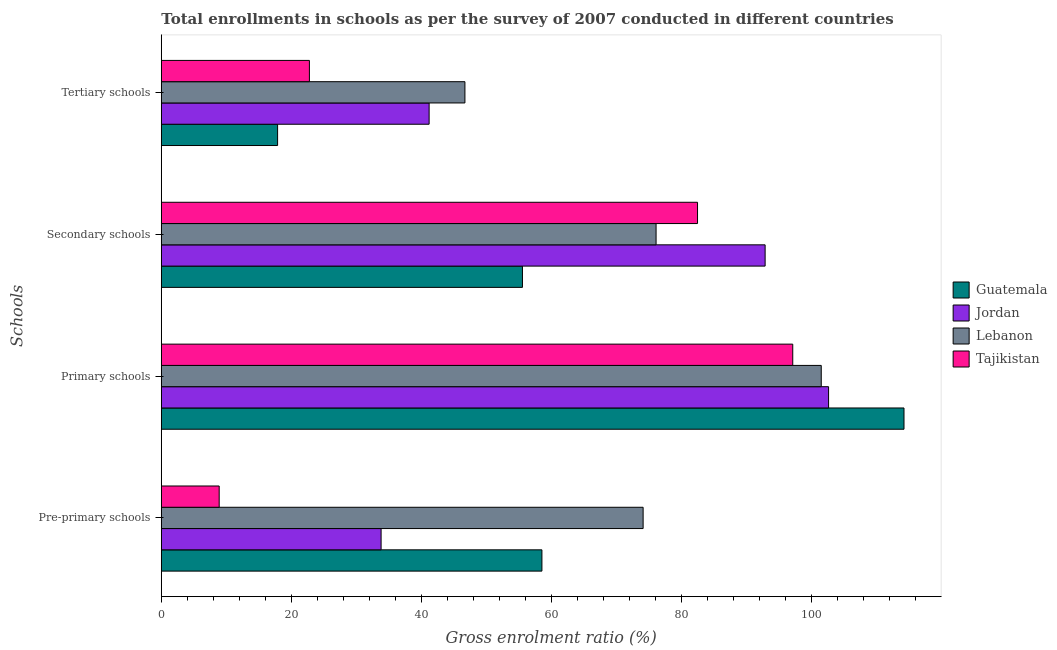How many different coloured bars are there?
Your answer should be compact. 4. Are the number of bars per tick equal to the number of legend labels?
Give a very brief answer. Yes. How many bars are there on the 4th tick from the top?
Your answer should be compact. 4. What is the label of the 2nd group of bars from the top?
Your response must be concise. Secondary schools. What is the gross enrolment ratio in tertiary schools in Guatemala?
Offer a very short reply. 17.88. Across all countries, what is the maximum gross enrolment ratio in primary schools?
Keep it short and to the point. 114.17. Across all countries, what is the minimum gross enrolment ratio in pre-primary schools?
Ensure brevity in your answer.  8.9. In which country was the gross enrolment ratio in tertiary schools maximum?
Your response must be concise. Lebanon. In which country was the gross enrolment ratio in tertiary schools minimum?
Ensure brevity in your answer.  Guatemala. What is the total gross enrolment ratio in pre-primary schools in the graph?
Offer a very short reply. 175.25. What is the difference between the gross enrolment ratio in pre-primary schools in Guatemala and that in Jordan?
Give a very brief answer. 24.72. What is the difference between the gross enrolment ratio in secondary schools in Jordan and the gross enrolment ratio in tertiary schools in Tajikistan?
Give a very brief answer. 70.05. What is the average gross enrolment ratio in primary schools per country?
Your response must be concise. 103.81. What is the difference between the gross enrolment ratio in primary schools and gross enrolment ratio in secondary schools in Guatemala?
Offer a terse response. 58.65. In how many countries, is the gross enrolment ratio in pre-primary schools greater than 12 %?
Your response must be concise. 3. What is the ratio of the gross enrolment ratio in tertiary schools in Lebanon to that in Guatemala?
Offer a very short reply. 2.61. Is the difference between the gross enrolment ratio in secondary schools in Jordan and Tajikistan greater than the difference between the gross enrolment ratio in pre-primary schools in Jordan and Tajikistan?
Offer a very short reply. No. What is the difference between the highest and the second highest gross enrolment ratio in pre-primary schools?
Provide a succinct answer. 15.56. What is the difference between the highest and the lowest gross enrolment ratio in secondary schools?
Your response must be concise. 37.3. Is the sum of the gross enrolment ratio in pre-primary schools in Lebanon and Tajikistan greater than the maximum gross enrolment ratio in secondary schools across all countries?
Keep it short and to the point. No. What does the 1st bar from the top in Secondary schools represents?
Your answer should be compact. Tajikistan. What does the 2nd bar from the bottom in Pre-primary schools represents?
Provide a short and direct response. Jordan. Is it the case that in every country, the sum of the gross enrolment ratio in pre-primary schools and gross enrolment ratio in primary schools is greater than the gross enrolment ratio in secondary schools?
Ensure brevity in your answer.  Yes. How many countries are there in the graph?
Provide a succinct answer. 4. What is the difference between two consecutive major ticks on the X-axis?
Make the answer very short. 20. Does the graph contain any zero values?
Give a very brief answer. No. Where does the legend appear in the graph?
Give a very brief answer. Center right. How many legend labels are there?
Give a very brief answer. 4. How are the legend labels stacked?
Provide a short and direct response. Vertical. What is the title of the graph?
Your answer should be very brief. Total enrollments in schools as per the survey of 2007 conducted in different countries. What is the label or title of the X-axis?
Provide a short and direct response. Gross enrolment ratio (%). What is the label or title of the Y-axis?
Provide a succinct answer. Schools. What is the Gross enrolment ratio (%) in Guatemala in Pre-primary schools?
Make the answer very short. 58.51. What is the Gross enrolment ratio (%) of Jordan in Pre-primary schools?
Make the answer very short. 33.78. What is the Gross enrolment ratio (%) of Lebanon in Pre-primary schools?
Provide a short and direct response. 74.07. What is the Gross enrolment ratio (%) of Tajikistan in Pre-primary schools?
Provide a succinct answer. 8.9. What is the Gross enrolment ratio (%) in Guatemala in Primary schools?
Your answer should be compact. 114.17. What is the Gross enrolment ratio (%) of Jordan in Primary schools?
Provide a short and direct response. 102.57. What is the Gross enrolment ratio (%) in Lebanon in Primary schools?
Keep it short and to the point. 101.45. What is the Gross enrolment ratio (%) in Tajikistan in Primary schools?
Your answer should be compact. 97.07. What is the Gross enrolment ratio (%) in Guatemala in Secondary schools?
Offer a very short reply. 55.51. What is the Gross enrolment ratio (%) of Jordan in Secondary schools?
Provide a succinct answer. 92.82. What is the Gross enrolment ratio (%) of Lebanon in Secondary schools?
Your response must be concise. 76.06. What is the Gross enrolment ratio (%) of Tajikistan in Secondary schools?
Provide a succinct answer. 82.43. What is the Gross enrolment ratio (%) in Guatemala in Tertiary schools?
Your answer should be very brief. 17.88. What is the Gross enrolment ratio (%) in Jordan in Tertiary schools?
Your answer should be very brief. 41.17. What is the Gross enrolment ratio (%) in Lebanon in Tertiary schools?
Your answer should be compact. 46.67. What is the Gross enrolment ratio (%) of Tajikistan in Tertiary schools?
Offer a very short reply. 22.76. Across all Schools, what is the maximum Gross enrolment ratio (%) in Guatemala?
Your response must be concise. 114.17. Across all Schools, what is the maximum Gross enrolment ratio (%) in Jordan?
Your response must be concise. 102.57. Across all Schools, what is the maximum Gross enrolment ratio (%) of Lebanon?
Offer a very short reply. 101.45. Across all Schools, what is the maximum Gross enrolment ratio (%) in Tajikistan?
Provide a succinct answer. 97.07. Across all Schools, what is the minimum Gross enrolment ratio (%) in Guatemala?
Ensure brevity in your answer.  17.88. Across all Schools, what is the minimum Gross enrolment ratio (%) of Jordan?
Ensure brevity in your answer.  33.78. Across all Schools, what is the minimum Gross enrolment ratio (%) of Lebanon?
Your answer should be very brief. 46.67. Across all Schools, what is the minimum Gross enrolment ratio (%) of Tajikistan?
Ensure brevity in your answer.  8.9. What is the total Gross enrolment ratio (%) in Guatemala in the graph?
Keep it short and to the point. 246.06. What is the total Gross enrolment ratio (%) in Jordan in the graph?
Provide a succinct answer. 270.35. What is the total Gross enrolment ratio (%) in Lebanon in the graph?
Your answer should be very brief. 298.24. What is the total Gross enrolment ratio (%) in Tajikistan in the graph?
Make the answer very short. 211.15. What is the difference between the Gross enrolment ratio (%) of Guatemala in Pre-primary schools and that in Primary schools?
Provide a succinct answer. -55.66. What is the difference between the Gross enrolment ratio (%) in Jordan in Pre-primary schools and that in Primary schools?
Keep it short and to the point. -68.79. What is the difference between the Gross enrolment ratio (%) of Lebanon in Pre-primary schools and that in Primary schools?
Ensure brevity in your answer.  -27.38. What is the difference between the Gross enrolment ratio (%) of Tajikistan in Pre-primary schools and that in Primary schools?
Offer a terse response. -88.17. What is the difference between the Gross enrolment ratio (%) of Guatemala in Pre-primary schools and that in Secondary schools?
Provide a succinct answer. 2.99. What is the difference between the Gross enrolment ratio (%) of Jordan in Pre-primary schools and that in Secondary schools?
Make the answer very short. -59.03. What is the difference between the Gross enrolment ratio (%) of Lebanon in Pre-primary schools and that in Secondary schools?
Offer a very short reply. -1.99. What is the difference between the Gross enrolment ratio (%) in Tajikistan in Pre-primary schools and that in Secondary schools?
Ensure brevity in your answer.  -73.53. What is the difference between the Gross enrolment ratio (%) of Guatemala in Pre-primary schools and that in Tertiary schools?
Your response must be concise. 40.63. What is the difference between the Gross enrolment ratio (%) in Jordan in Pre-primary schools and that in Tertiary schools?
Keep it short and to the point. -7.38. What is the difference between the Gross enrolment ratio (%) in Lebanon in Pre-primary schools and that in Tertiary schools?
Ensure brevity in your answer.  27.39. What is the difference between the Gross enrolment ratio (%) of Tajikistan in Pre-primary schools and that in Tertiary schools?
Your answer should be compact. -13.87. What is the difference between the Gross enrolment ratio (%) in Guatemala in Primary schools and that in Secondary schools?
Make the answer very short. 58.65. What is the difference between the Gross enrolment ratio (%) in Jordan in Primary schools and that in Secondary schools?
Keep it short and to the point. 9.76. What is the difference between the Gross enrolment ratio (%) of Lebanon in Primary schools and that in Secondary schools?
Your answer should be compact. 25.39. What is the difference between the Gross enrolment ratio (%) in Tajikistan in Primary schools and that in Secondary schools?
Give a very brief answer. 14.64. What is the difference between the Gross enrolment ratio (%) of Guatemala in Primary schools and that in Tertiary schools?
Give a very brief answer. 96.29. What is the difference between the Gross enrolment ratio (%) of Jordan in Primary schools and that in Tertiary schools?
Provide a short and direct response. 61.41. What is the difference between the Gross enrolment ratio (%) of Lebanon in Primary schools and that in Tertiary schools?
Give a very brief answer. 54.77. What is the difference between the Gross enrolment ratio (%) of Tajikistan in Primary schools and that in Tertiary schools?
Provide a short and direct response. 74.3. What is the difference between the Gross enrolment ratio (%) in Guatemala in Secondary schools and that in Tertiary schools?
Your answer should be compact. 37.64. What is the difference between the Gross enrolment ratio (%) in Jordan in Secondary schools and that in Tertiary schools?
Ensure brevity in your answer.  51.65. What is the difference between the Gross enrolment ratio (%) of Lebanon in Secondary schools and that in Tertiary schools?
Ensure brevity in your answer.  29.38. What is the difference between the Gross enrolment ratio (%) of Tajikistan in Secondary schools and that in Tertiary schools?
Your answer should be compact. 59.66. What is the difference between the Gross enrolment ratio (%) in Guatemala in Pre-primary schools and the Gross enrolment ratio (%) in Jordan in Primary schools?
Keep it short and to the point. -44.07. What is the difference between the Gross enrolment ratio (%) in Guatemala in Pre-primary schools and the Gross enrolment ratio (%) in Lebanon in Primary schools?
Ensure brevity in your answer.  -42.94. What is the difference between the Gross enrolment ratio (%) of Guatemala in Pre-primary schools and the Gross enrolment ratio (%) of Tajikistan in Primary schools?
Provide a succinct answer. -38.56. What is the difference between the Gross enrolment ratio (%) of Jordan in Pre-primary schools and the Gross enrolment ratio (%) of Lebanon in Primary schools?
Offer a terse response. -67.66. What is the difference between the Gross enrolment ratio (%) of Jordan in Pre-primary schools and the Gross enrolment ratio (%) of Tajikistan in Primary schools?
Keep it short and to the point. -63.28. What is the difference between the Gross enrolment ratio (%) of Lebanon in Pre-primary schools and the Gross enrolment ratio (%) of Tajikistan in Primary schools?
Your answer should be very brief. -23. What is the difference between the Gross enrolment ratio (%) of Guatemala in Pre-primary schools and the Gross enrolment ratio (%) of Jordan in Secondary schools?
Give a very brief answer. -34.31. What is the difference between the Gross enrolment ratio (%) in Guatemala in Pre-primary schools and the Gross enrolment ratio (%) in Lebanon in Secondary schools?
Provide a short and direct response. -17.55. What is the difference between the Gross enrolment ratio (%) in Guatemala in Pre-primary schools and the Gross enrolment ratio (%) in Tajikistan in Secondary schools?
Your answer should be very brief. -23.92. What is the difference between the Gross enrolment ratio (%) in Jordan in Pre-primary schools and the Gross enrolment ratio (%) in Lebanon in Secondary schools?
Ensure brevity in your answer.  -42.27. What is the difference between the Gross enrolment ratio (%) of Jordan in Pre-primary schools and the Gross enrolment ratio (%) of Tajikistan in Secondary schools?
Keep it short and to the point. -48.64. What is the difference between the Gross enrolment ratio (%) of Lebanon in Pre-primary schools and the Gross enrolment ratio (%) of Tajikistan in Secondary schools?
Give a very brief answer. -8.36. What is the difference between the Gross enrolment ratio (%) of Guatemala in Pre-primary schools and the Gross enrolment ratio (%) of Jordan in Tertiary schools?
Make the answer very short. 17.34. What is the difference between the Gross enrolment ratio (%) in Guatemala in Pre-primary schools and the Gross enrolment ratio (%) in Lebanon in Tertiary schools?
Give a very brief answer. 11.84. What is the difference between the Gross enrolment ratio (%) in Guatemala in Pre-primary schools and the Gross enrolment ratio (%) in Tajikistan in Tertiary schools?
Offer a very short reply. 35.74. What is the difference between the Gross enrolment ratio (%) in Jordan in Pre-primary schools and the Gross enrolment ratio (%) in Lebanon in Tertiary schools?
Your answer should be compact. -12.89. What is the difference between the Gross enrolment ratio (%) of Jordan in Pre-primary schools and the Gross enrolment ratio (%) of Tajikistan in Tertiary schools?
Offer a terse response. 11.02. What is the difference between the Gross enrolment ratio (%) in Lebanon in Pre-primary schools and the Gross enrolment ratio (%) in Tajikistan in Tertiary schools?
Provide a short and direct response. 51.3. What is the difference between the Gross enrolment ratio (%) of Guatemala in Primary schools and the Gross enrolment ratio (%) of Jordan in Secondary schools?
Your answer should be very brief. 21.35. What is the difference between the Gross enrolment ratio (%) in Guatemala in Primary schools and the Gross enrolment ratio (%) in Lebanon in Secondary schools?
Keep it short and to the point. 38.11. What is the difference between the Gross enrolment ratio (%) in Guatemala in Primary schools and the Gross enrolment ratio (%) in Tajikistan in Secondary schools?
Your answer should be compact. 31.74. What is the difference between the Gross enrolment ratio (%) in Jordan in Primary schools and the Gross enrolment ratio (%) in Lebanon in Secondary schools?
Your answer should be compact. 26.52. What is the difference between the Gross enrolment ratio (%) of Jordan in Primary schools and the Gross enrolment ratio (%) of Tajikistan in Secondary schools?
Offer a very short reply. 20.15. What is the difference between the Gross enrolment ratio (%) in Lebanon in Primary schools and the Gross enrolment ratio (%) in Tajikistan in Secondary schools?
Keep it short and to the point. 19.02. What is the difference between the Gross enrolment ratio (%) in Guatemala in Primary schools and the Gross enrolment ratio (%) in Jordan in Tertiary schools?
Your response must be concise. 73. What is the difference between the Gross enrolment ratio (%) in Guatemala in Primary schools and the Gross enrolment ratio (%) in Lebanon in Tertiary schools?
Your response must be concise. 67.5. What is the difference between the Gross enrolment ratio (%) of Guatemala in Primary schools and the Gross enrolment ratio (%) of Tajikistan in Tertiary schools?
Your answer should be very brief. 91.4. What is the difference between the Gross enrolment ratio (%) in Jordan in Primary schools and the Gross enrolment ratio (%) in Lebanon in Tertiary schools?
Offer a terse response. 55.9. What is the difference between the Gross enrolment ratio (%) of Jordan in Primary schools and the Gross enrolment ratio (%) of Tajikistan in Tertiary schools?
Ensure brevity in your answer.  79.81. What is the difference between the Gross enrolment ratio (%) in Lebanon in Primary schools and the Gross enrolment ratio (%) in Tajikistan in Tertiary schools?
Provide a succinct answer. 78.68. What is the difference between the Gross enrolment ratio (%) of Guatemala in Secondary schools and the Gross enrolment ratio (%) of Jordan in Tertiary schools?
Your response must be concise. 14.35. What is the difference between the Gross enrolment ratio (%) in Guatemala in Secondary schools and the Gross enrolment ratio (%) in Lebanon in Tertiary schools?
Your response must be concise. 8.84. What is the difference between the Gross enrolment ratio (%) in Guatemala in Secondary schools and the Gross enrolment ratio (%) in Tajikistan in Tertiary schools?
Provide a short and direct response. 32.75. What is the difference between the Gross enrolment ratio (%) of Jordan in Secondary schools and the Gross enrolment ratio (%) of Lebanon in Tertiary schools?
Offer a terse response. 46.15. What is the difference between the Gross enrolment ratio (%) of Jordan in Secondary schools and the Gross enrolment ratio (%) of Tajikistan in Tertiary schools?
Your answer should be compact. 70.05. What is the difference between the Gross enrolment ratio (%) in Lebanon in Secondary schools and the Gross enrolment ratio (%) in Tajikistan in Tertiary schools?
Make the answer very short. 53.29. What is the average Gross enrolment ratio (%) of Guatemala per Schools?
Keep it short and to the point. 61.52. What is the average Gross enrolment ratio (%) of Jordan per Schools?
Provide a succinct answer. 67.59. What is the average Gross enrolment ratio (%) in Lebanon per Schools?
Your response must be concise. 74.56. What is the average Gross enrolment ratio (%) in Tajikistan per Schools?
Give a very brief answer. 52.79. What is the difference between the Gross enrolment ratio (%) in Guatemala and Gross enrolment ratio (%) in Jordan in Pre-primary schools?
Offer a terse response. 24.72. What is the difference between the Gross enrolment ratio (%) in Guatemala and Gross enrolment ratio (%) in Lebanon in Pre-primary schools?
Your response must be concise. -15.56. What is the difference between the Gross enrolment ratio (%) of Guatemala and Gross enrolment ratio (%) of Tajikistan in Pre-primary schools?
Your answer should be very brief. 49.61. What is the difference between the Gross enrolment ratio (%) of Jordan and Gross enrolment ratio (%) of Lebanon in Pre-primary schools?
Your answer should be very brief. -40.28. What is the difference between the Gross enrolment ratio (%) of Jordan and Gross enrolment ratio (%) of Tajikistan in Pre-primary schools?
Keep it short and to the point. 24.89. What is the difference between the Gross enrolment ratio (%) of Lebanon and Gross enrolment ratio (%) of Tajikistan in Pre-primary schools?
Provide a short and direct response. 65.17. What is the difference between the Gross enrolment ratio (%) in Guatemala and Gross enrolment ratio (%) in Jordan in Primary schools?
Make the answer very short. 11.59. What is the difference between the Gross enrolment ratio (%) in Guatemala and Gross enrolment ratio (%) in Lebanon in Primary schools?
Your answer should be very brief. 12.72. What is the difference between the Gross enrolment ratio (%) of Guatemala and Gross enrolment ratio (%) of Tajikistan in Primary schools?
Ensure brevity in your answer.  17.1. What is the difference between the Gross enrolment ratio (%) of Jordan and Gross enrolment ratio (%) of Lebanon in Primary schools?
Make the answer very short. 1.13. What is the difference between the Gross enrolment ratio (%) of Jordan and Gross enrolment ratio (%) of Tajikistan in Primary schools?
Your response must be concise. 5.51. What is the difference between the Gross enrolment ratio (%) of Lebanon and Gross enrolment ratio (%) of Tajikistan in Primary schools?
Provide a succinct answer. 4.38. What is the difference between the Gross enrolment ratio (%) of Guatemala and Gross enrolment ratio (%) of Jordan in Secondary schools?
Provide a short and direct response. -37.3. What is the difference between the Gross enrolment ratio (%) in Guatemala and Gross enrolment ratio (%) in Lebanon in Secondary schools?
Keep it short and to the point. -20.54. What is the difference between the Gross enrolment ratio (%) in Guatemala and Gross enrolment ratio (%) in Tajikistan in Secondary schools?
Offer a terse response. -26.91. What is the difference between the Gross enrolment ratio (%) of Jordan and Gross enrolment ratio (%) of Lebanon in Secondary schools?
Offer a very short reply. 16.76. What is the difference between the Gross enrolment ratio (%) in Jordan and Gross enrolment ratio (%) in Tajikistan in Secondary schools?
Offer a very short reply. 10.39. What is the difference between the Gross enrolment ratio (%) in Lebanon and Gross enrolment ratio (%) in Tajikistan in Secondary schools?
Make the answer very short. -6.37. What is the difference between the Gross enrolment ratio (%) in Guatemala and Gross enrolment ratio (%) in Jordan in Tertiary schools?
Give a very brief answer. -23.29. What is the difference between the Gross enrolment ratio (%) in Guatemala and Gross enrolment ratio (%) in Lebanon in Tertiary schools?
Give a very brief answer. -28.8. What is the difference between the Gross enrolment ratio (%) in Guatemala and Gross enrolment ratio (%) in Tajikistan in Tertiary schools?
Your answer should be very brief. -4.89. What is the difference between the Gross enrolment ratio (%) of Jordan and Gross enrolment ratio (%) of Lebanon in Tertiary schools?
Your response must be concise. -5.5. What is the difference between the Gross enrolment ratio (%) of Jordan and Gross enrolment ratio (%) of Tajikistan in Tertiary schools?
Your answer should be compact. 18.4. What is the difference between the Gross enrolment ratio (%) in Lebanon and Gross enrolment ratio (%) in Tajikistan in Tertiary schools?
Your answer should be very brief. 23.91. What is the ratio of the Gross enrolment ratio (%) of Guatemala in Pre-primary schools to that in Primary schools?
Give a very brief answer. 0.51. What is the ratio of the Gross enrolment ratio (%) in Jordan in Pre-primary schools to that in Primary schools?
Provide a short and direct response. 0.33. What is the ratio of the Gross enrolment ratio (%) in Lebanon in Pre-primary schools to that in Primary schools?
Keep it short and to the point. 0.73. What is the ratio of the Gross enrolment ratio (%) of Tajikistan in Pre-primary schools to that in Primary schools?
Offer a terse response. 0.09. What is the ratio of the Gross enrolment ratio (%) of Guatemala in Pre-primary schools to that in Secondary schools?
Make the answer very short. 1.05. What is the ratio of the Gross enrolment ratio (%) of Jordan in Pre-primary schools to that in Secondary schools?
Offer a terse response. 0.36. What is the ratio of the Gross enrolment ratio (%) in Lebanon in Pre-primary schools to that in Secondary schools?
Your answer should be very brief. 0.97. What is the ratio of the Gross enrolment ratio (%) of Tajikistan in Pre-primary schools to that in Secondary schools?
Your answer should be very brief. 0.11. What is the ratio of the Gross enrolment ratio (%) of Guatemala in Pre-primary schools to that in Tertiary schools?
Provide a short and direct response. 3.27. What is the ratio of the Gross enrolment ratio (%) in Jordan in Pre-primary schools to that in Tertiary schools?
Offer a terse response. 0.82. What is the ratio of the Gross enrolment ratio (%) of Lebanon in Pre-primary schools to that in Tertiary schools?
Your answer should be compact. 1.59. What is the ratio of the Gross enrolment ratio (%) in Tajikistan in Pre-primary schools to that in Tertiary schools?
Your answer should be compact. 0.39. What is the ratio of the Gross enrolment ratio (%) of Guatemala in Primary schools to that in Secondary schools?
Give a very brief answer. 2.06. What is the ratio of the Gross enrolment ratio (%) of Jordan in Primary schools to that in Secondary schools?
Your response must be concise. 1.11. What is the ratio of the Gross enrolment ratio (%) of Lebanon in Primary schools to that in Secondary schools?
Your answer should be compact. 1.33. What is the ratio of the Gross enrolment ratio (%) of Tajikistan in Primary schools to that in Secondary schools?
Make the answer very short. 1.18. What is the ratio of the Gross enrolment ratio (%) in Guatemala in Primary schools to that in Tertiary schools?
Offer a very short reply. 6.39. What is the ratio of the Gross enrolment ratio (%) in Jordan in Primary schools to that in Tertiary schools?
Ensure brevity in your answer.  2.49. What is the ratio of the Gross enrolment ratio (%) of Lebanon in Primary schools to that in Tertiary schools?
Make the answer very short. 2.17. What is the ratio of the Gross enrolment ratio (%) of Tajikistan in Primary schools to that in Tertiary schools?
Ensure brevity in your answer.  4.26. What is the ratio of the Gross enrolment ratio (%) in Guatemala in Secondary schools to that in Tertiary schools?
Give a very brief answer. 3.11. What is the ratio of the Gross enrolment ratio (%) in Jordan in Secondary schools to that in Tertiary schools?
Provide a succinct answer. 2.25. What is the ratio of the Gross enrolment ratio (%) in Lebanon in Secondary schools to that in Tertiary schools?
Provide a short and direct response. 1.63. What is the ratio of the Gross enrolment ratio (%) in Tajikistan in Secondary schools to that in Tertiary schools?
Your response must be concise. 3.62. What is the difference between the highest and the second highest Gross enrolment ratio (%) of Guatemala?
Your response must be concise. 55.66. What is the difference between the highest and the second highest Gross enrolment ratio (%) of Jordan?
Offer a very short reply. 9.76. What is the difference between the highest and the second highest Gross enrolment ratio (%) in Lebanon?
Your answer should be compact. 25.39. What is the difference between the highest and the second highest Gross enrolment ratio (%) in Tajikistan?
Ensure brevity in your answer.  14.64. What is the difference between the highest and the lowest Gross enrolment ratio (%) of Guatemala?
Ensure brevity in your answer.  96.29. What is the difference between the highest and the lowest Gross enrolment ratio (%) in Jordan?
Your answer should be very brief. 68.79. What is the difference between the highest and the lowest Gross enrolment ratio (%) in Lebanon?
Ensure brevity in your answer.  54.77. What is the difference between the highest and the lowest Gross enrolment ratio (%) of Tajikistan?
Your answer should be compact. 88.17. 